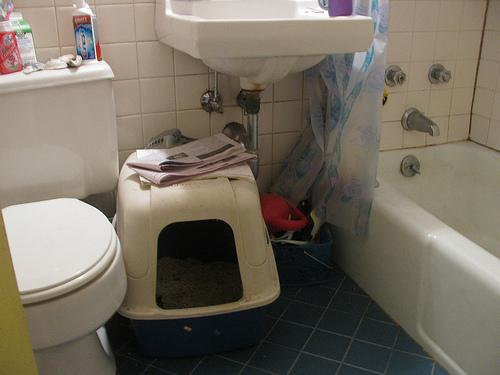Question: what is under the sink?
Choices:
A. Pipes.
B. Cat's litter box.
C. Cleaning supplies.
D. Food.
Answer with the letter. Answer: B Question: why the litter box in the bathroom?
Choices:
A. Smell.
B. So cat can use it.
C. Bathroom has vent.
D. No other place.
Answer with the letter. Answer: B Question: who is using the bathroom?
Choices:
A. Elvis.
B. Don Simpson.
C. Lenny Bruce.
D. No one.
Answer with the letter. Answer: D Question: what is the color of the floor?
Choices:
A. Red.
B. Green.
C. White.
D. Blue.
Answer with the letter. Answer: D 